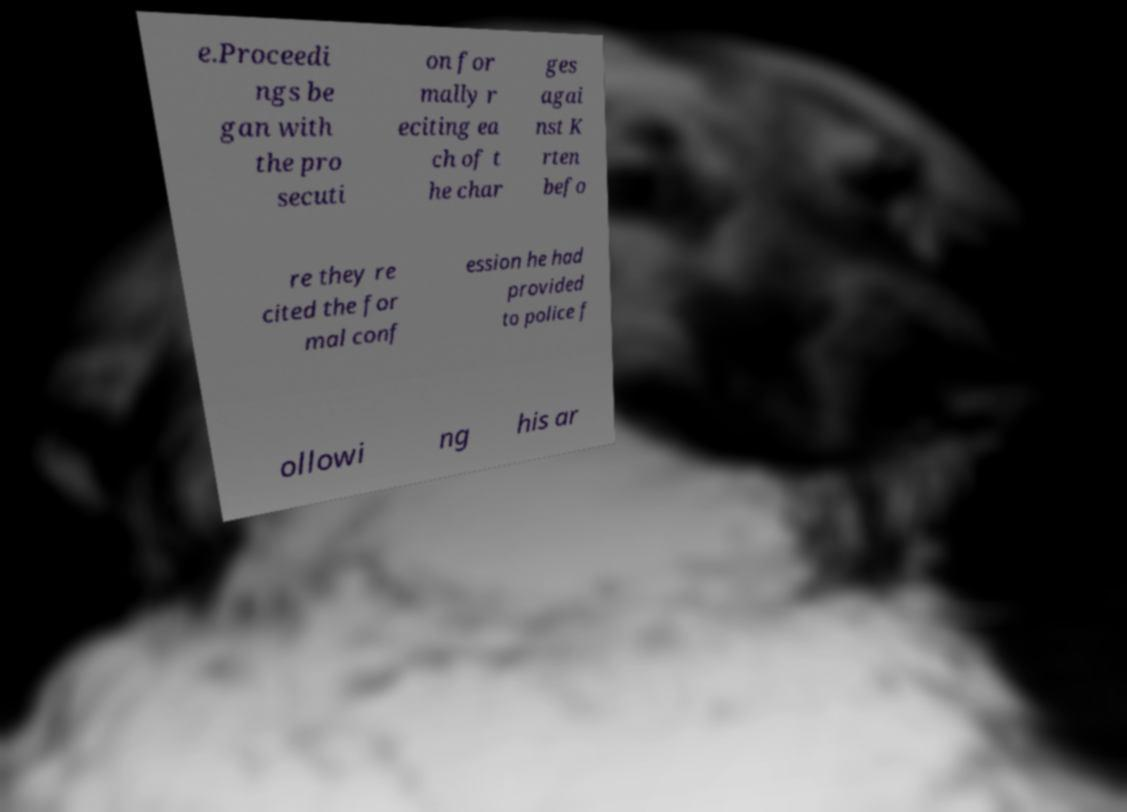I need the written content from this picture converted into text. Can you do that? e.Proceedi ngs be gan with the pro secuti on for mally r eciting ea ch of t he char ges agai nst K rten befo re they re cited the for mal conf ession he had provided to police f ollowi ng his ar 